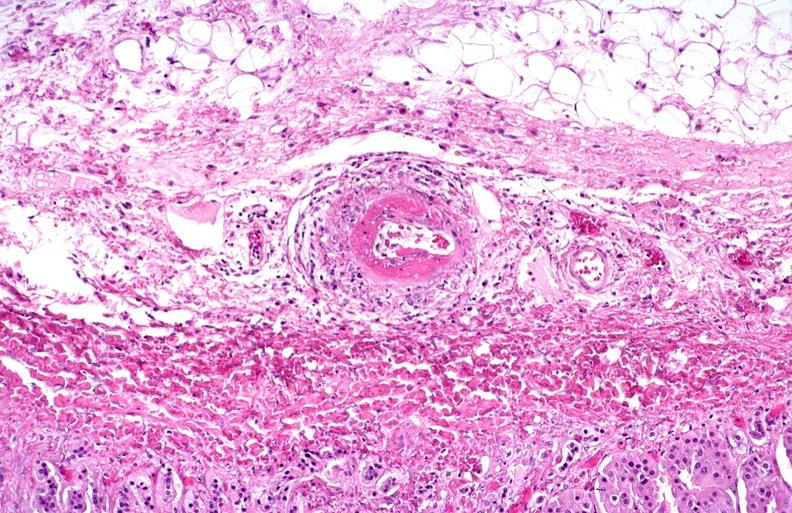s lymphangiomatosis present?
Answer the question using a single word or phrase. No 